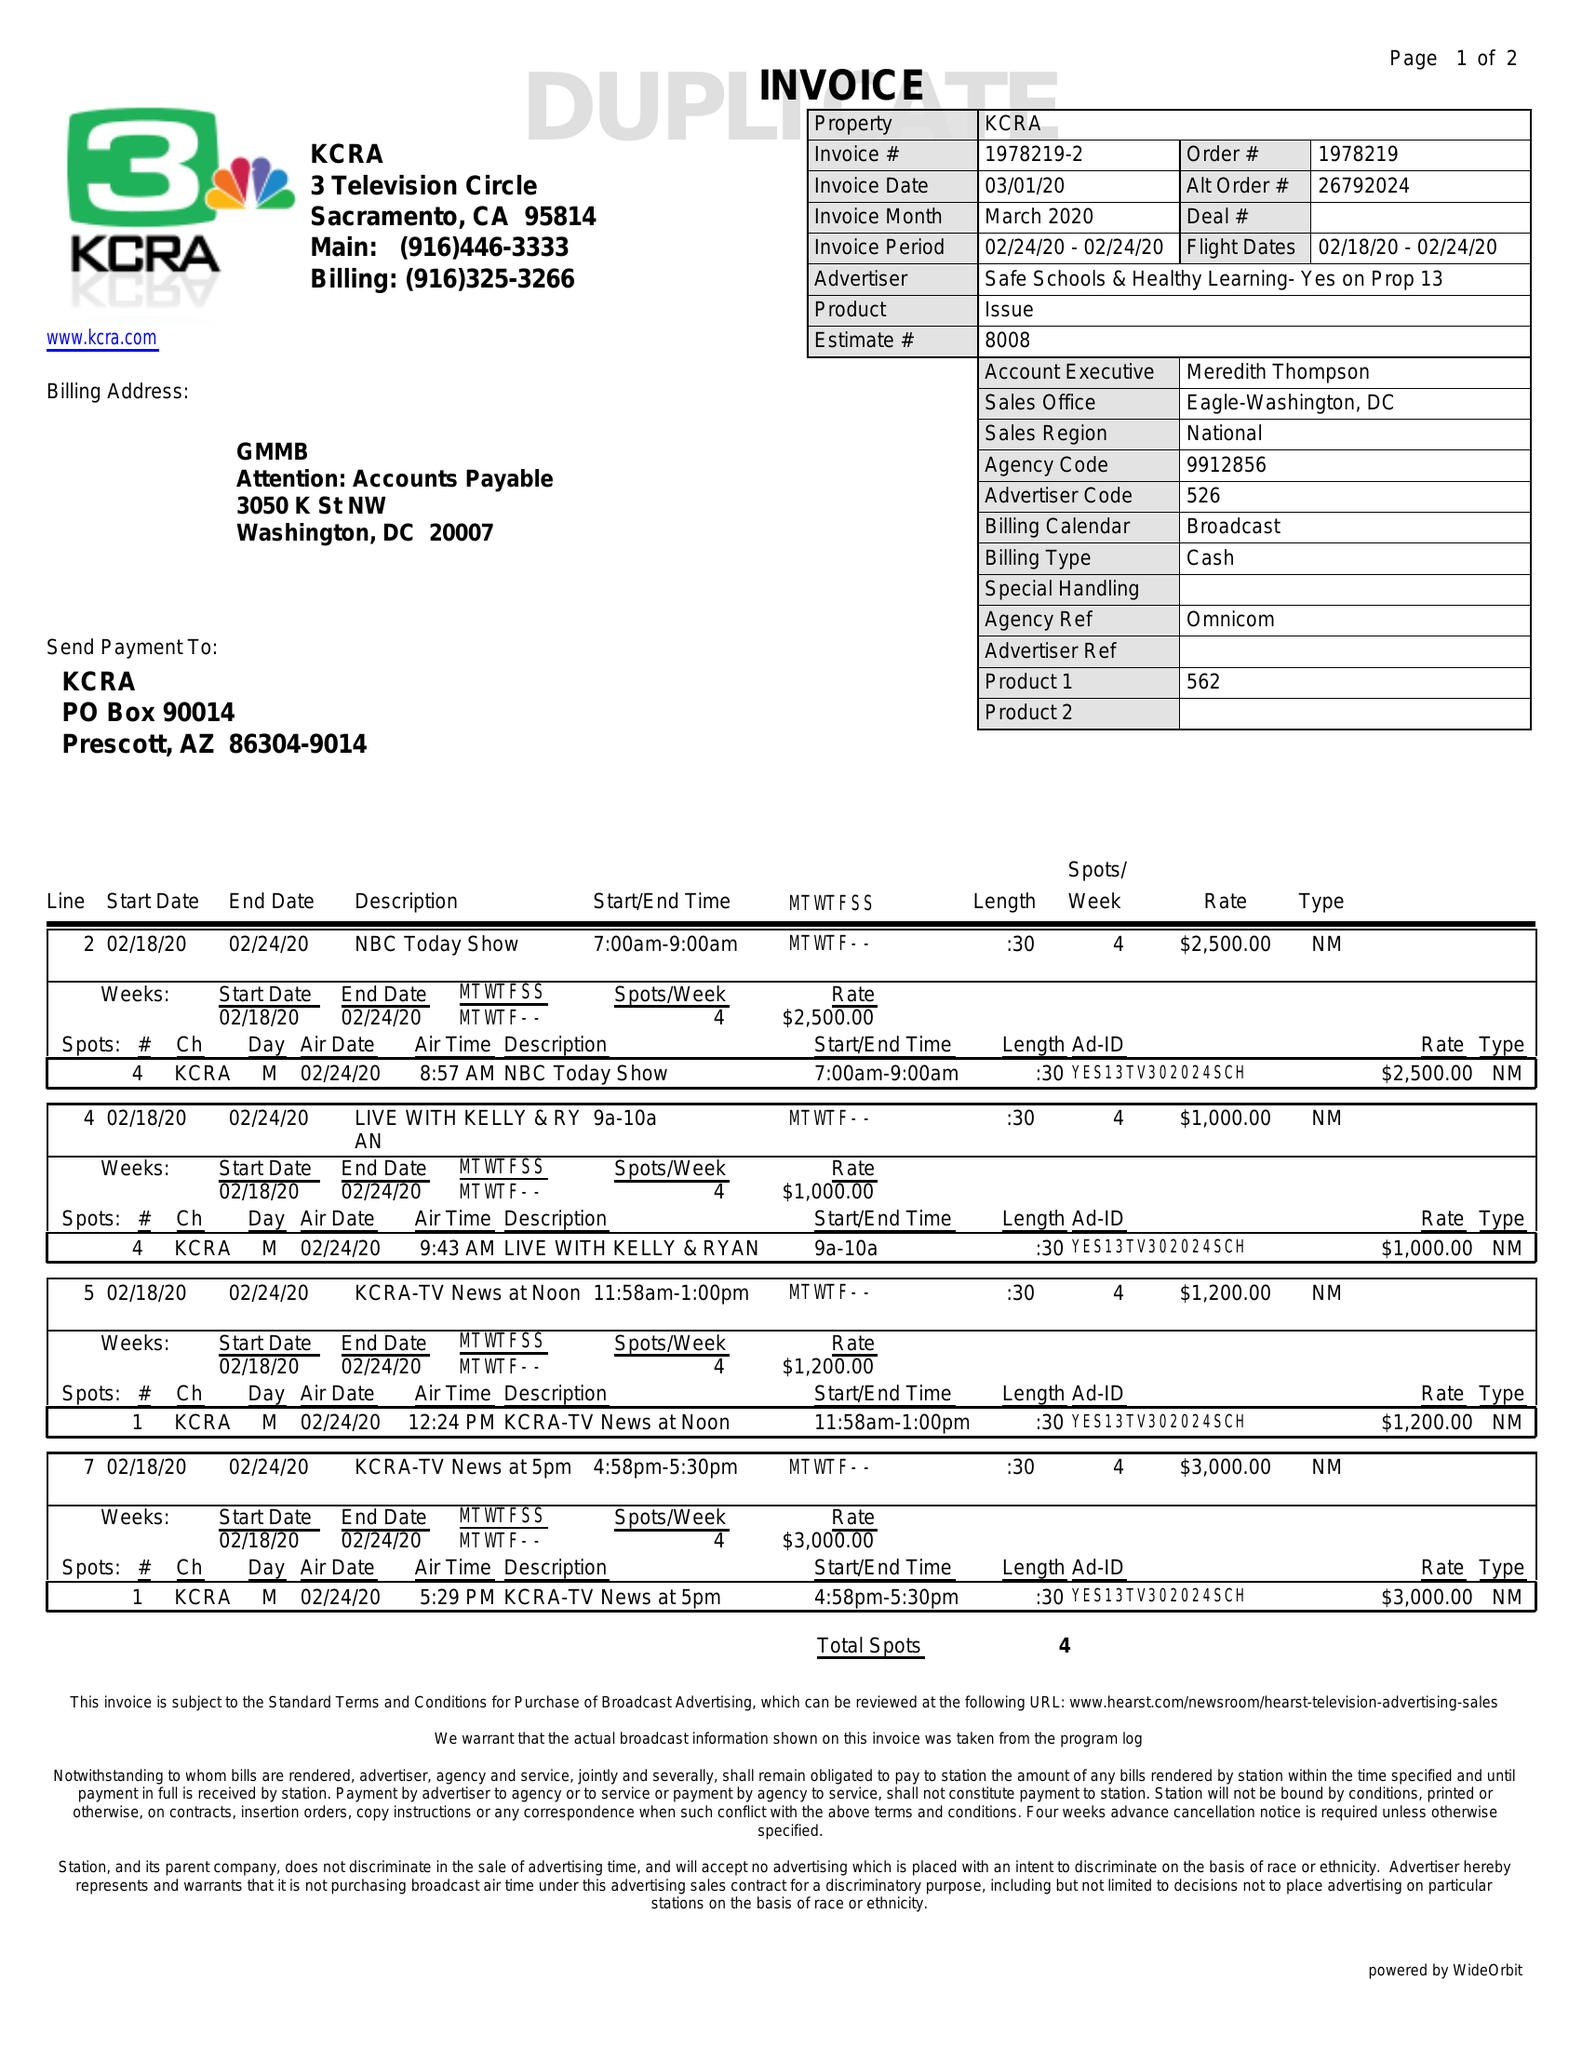What is the value for the flight_from?
Answer the question using a single word or phrase. 02/18/20 